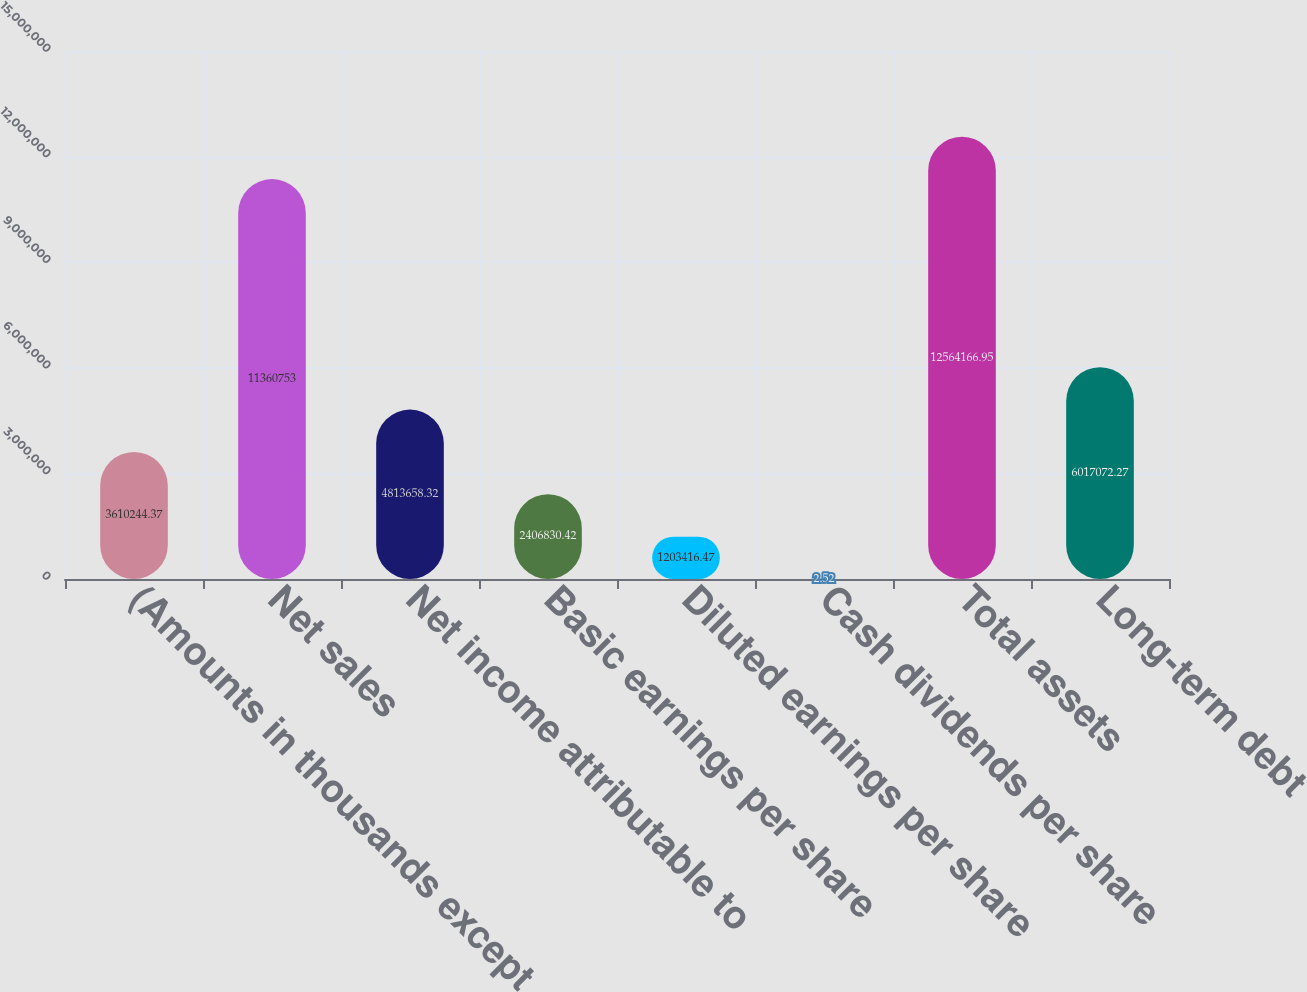Convert chart. <chart><loc_0><loc_0><loc_500><loc_500><bar_chart><fcel>(Amounts in thousands except<fcel>Net sales<fcel>Net income attributable to<fcel>Basic earnings per share<fcel>Diluted earnings per share<fcel>Cash dividends per share<fcel>Total assets<fcel>Long-term debt<nl><fcel>3.61024e+06<fcel>1.13608e+07<fcel>4.81366e+06<fcel>2.40683e+06<fcel>1.20342e+06<fcel>2.52<fcel>1.25642e+07<fcel>6.01707e+06<nl></chart> 